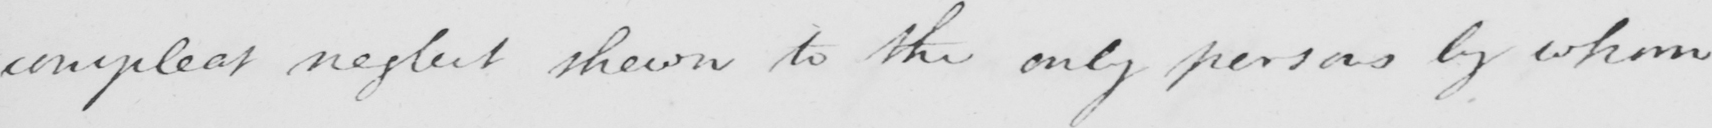Can you read and transcribe this handwriting? compleat neglect shown to the only persons by whom 